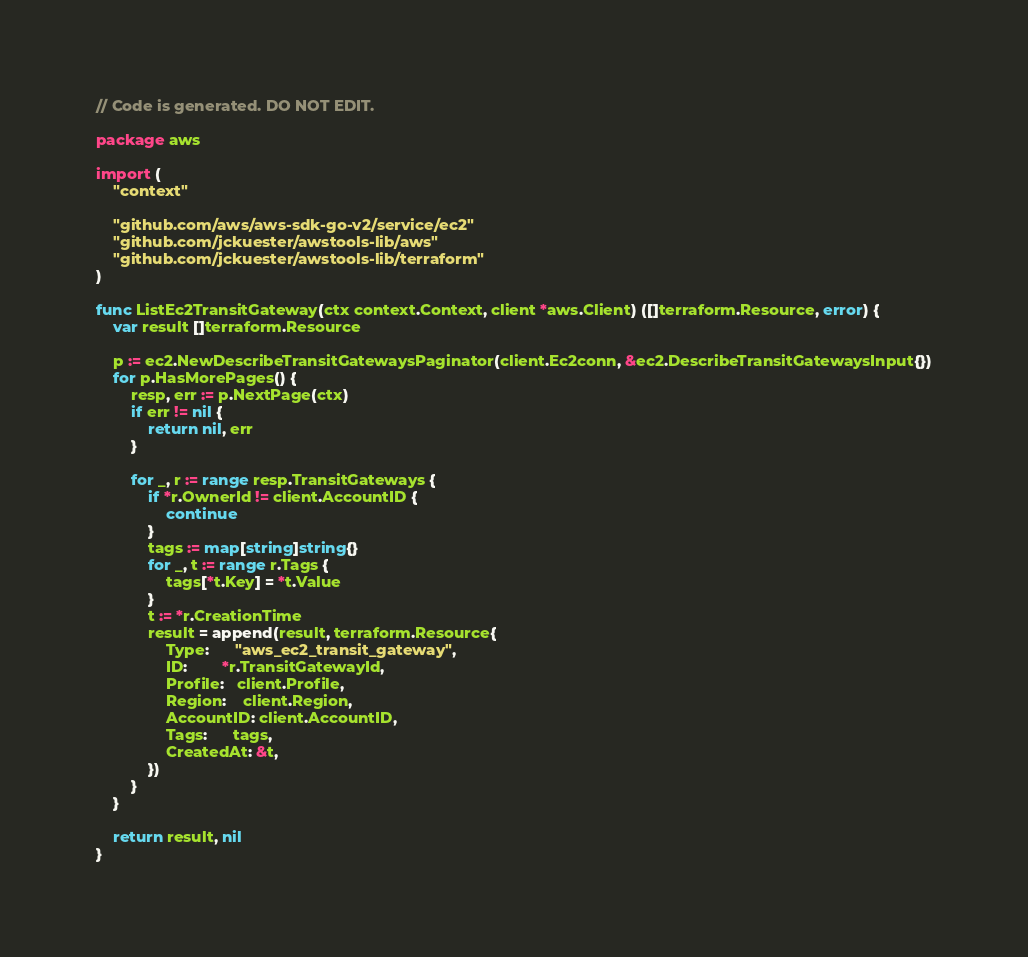Convert code to text. <code><loc_0><loc_0><loc_500><loc_500><_Go_>// Code is generated. DO NOT EDIT.

package aws

import (
	"context"

	"github.com/aws/aws-sdk-go-v2/service/ec2"
	"github.com/jckuester/awstools-lib/aws"
	"github.com/jckuester/awstools-lib/terraform"
)

func ListEc2TransitGateway(ctx context.Context, client *aws.Client) ([]terraform.Resource, error) {
	var result []terraform.Resource

	p := ec2.NewDescribeTransitGatewaysPaginator(client.Ec2conn, &ec2.DescribeTransitGatewaysInput{})
	for p.HasMorePages() {
		resp, err := p.NextPage(ctx)
		if err != nil {
			return nil, err
		}

		for _, r := range resp.TransitGateways {
			if *r.OwnerId != client.AccountID {
				continue
			}
			tags := map[string]string{}
			for _, t := range r.Tags {
				tags[*t.Key] = *t.Value
			}
			t := *r.CreationTime
			result = append(result, terraform.Resource{
				Type:      "aws_ec2_transit_gateway",
				ID:        *r.TransitGatewayId,
				Profile:   client.Profile,
				Region:    client.Region,
				AccountID: client.AccountID,
				Tags:      tags,
				CreatedAt: &t,
			})
		}
	}

	return result, nil
}
</code> 